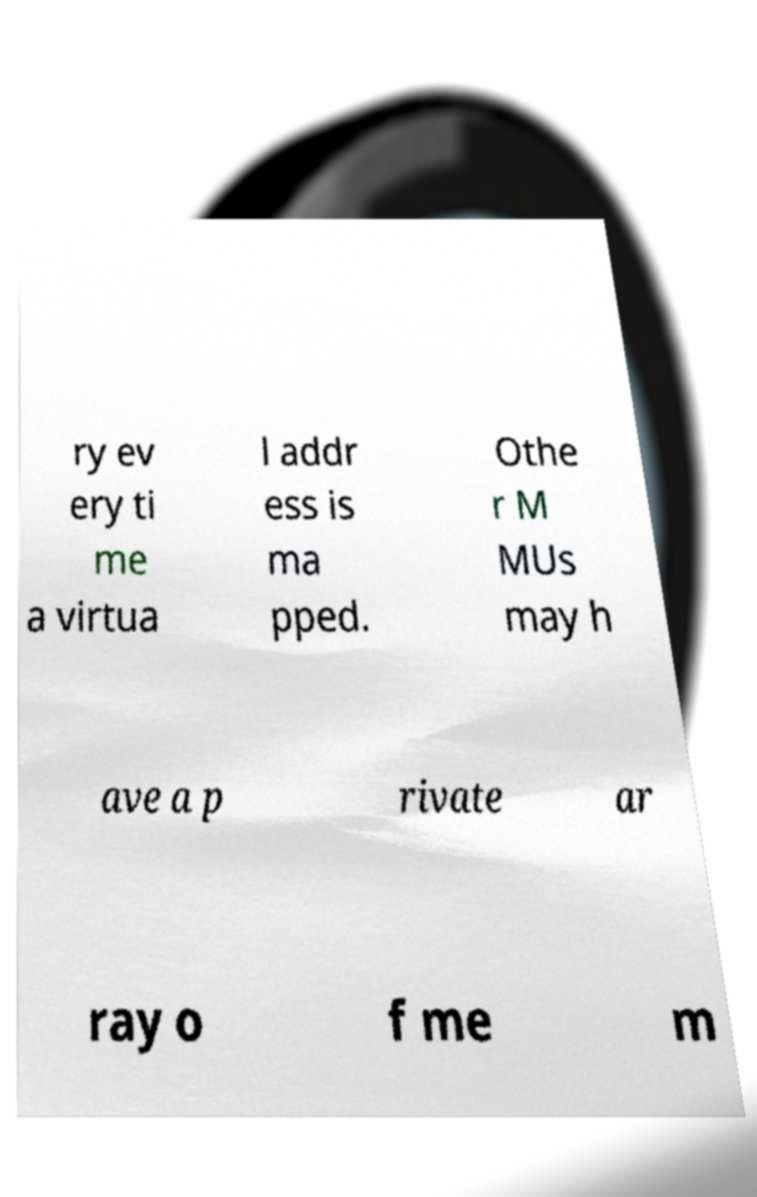What messages or text are displayed in this image? I need them in a readable, typed format. ry ev ery ti me a virtua l addr ess is ma pped. Othe r M MUs may h ave a p rivate ar ray o f me m 